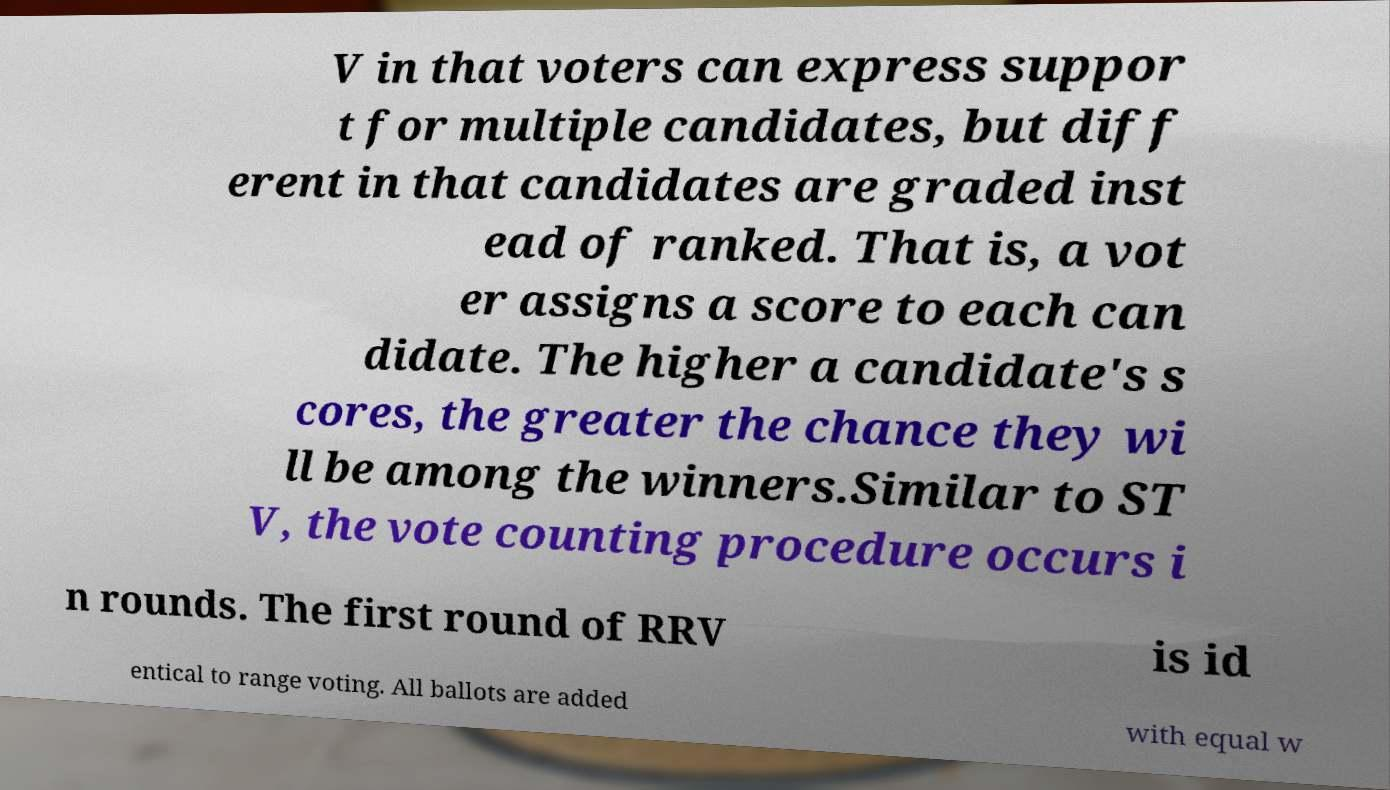What messages or text are displayed in this image? I need them in a readable, typed format. V in that voters can express suppor t for multiple candidates, but diff erent in that candidates are graded inst ead of ranked. That is, a vot er assigns a score to each can didate. The higher a candidate's s cores, the greater the chance they wi ll be among the winners.Similar to ST V, the vote counting procedure occurs i n rounds. The first round of RRV is id entical to range voting. All ballots are added with equal w 